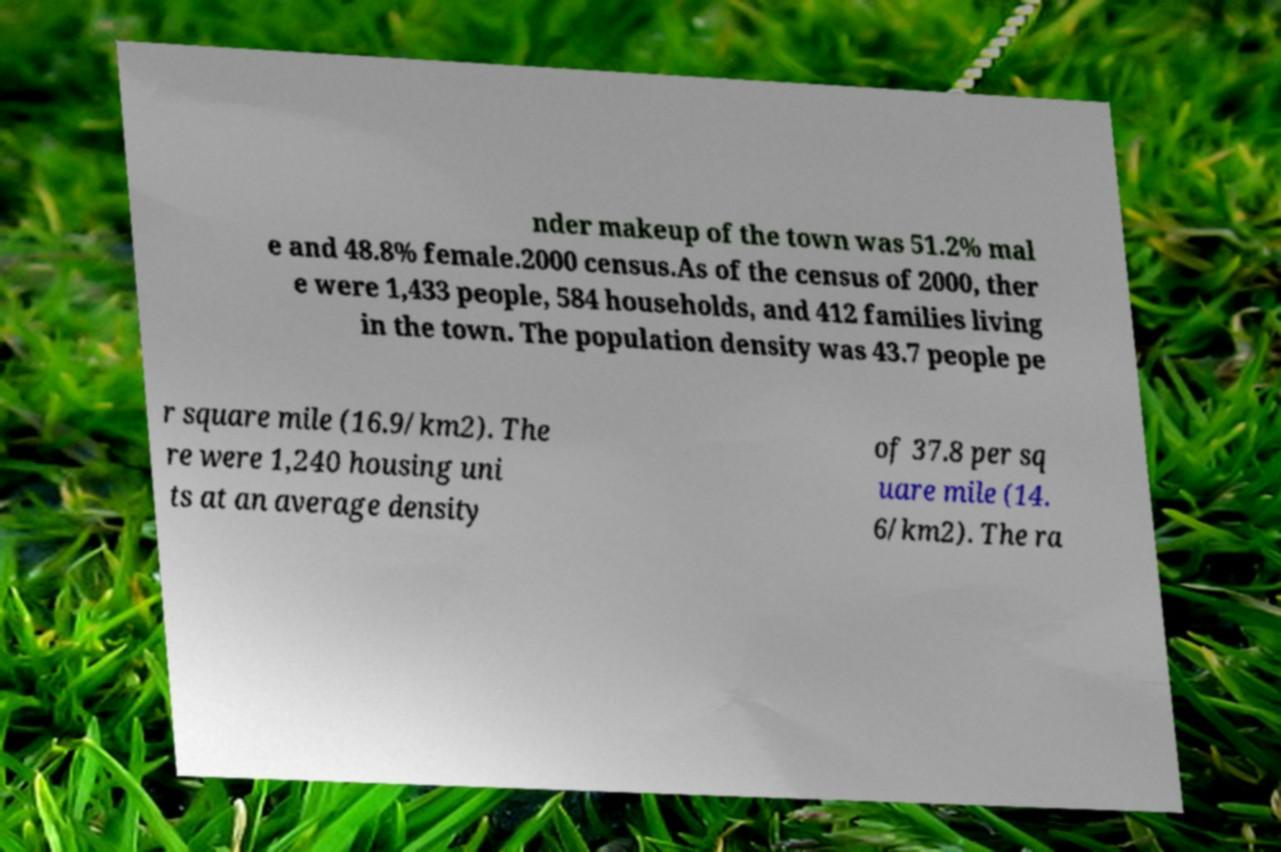What messages or text are displayed in this image? I need them in a readable, typed format. nder makeup of the town was 51.2% mal e and 48.8% female.2000 census.As of the census of 2000, ther e were 1,433 people, 584 households, and 412 families living in the town. The population density was 43.7 people pe r square mile (16.9/km2). The re were 1,240 housing uni ts at an average density of 37.8 per sq uare mile (14. 6/km2). The ra 